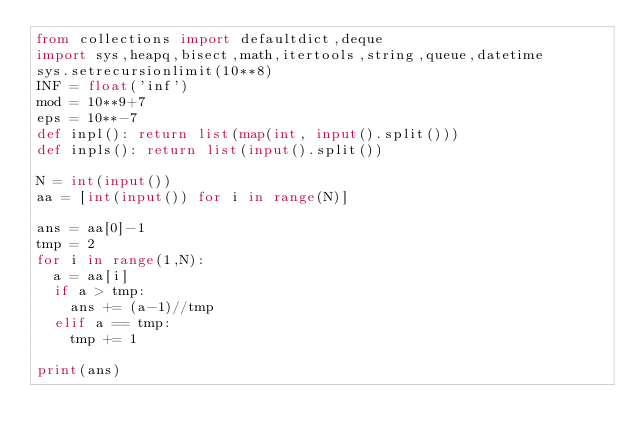Convert code to text. <code><loc_0><loc_0><loc_500><loc_500><_Python_>from collections import defaultdict,deque
import sys,heapq,bisect,math,itertools,string,queue,datetime
sys.setrecursionlimit(10**8)
INF = float('inf')
mod = 10**9+7
eps = 10**-7
def inpl(): return list(map(int, input().split()))
def inpls(): return list(input().split())

N = int(input())
aa = [int(input()) for i in range(N)]

ans = aa[0]-1
tmp = 2
for i in range(1,N):
	a = aa[i]
	if a > tmp:
		ans += (a-1)//tmp
	elif a == tmp:
		tmp += 1

print(ans)
</code> 